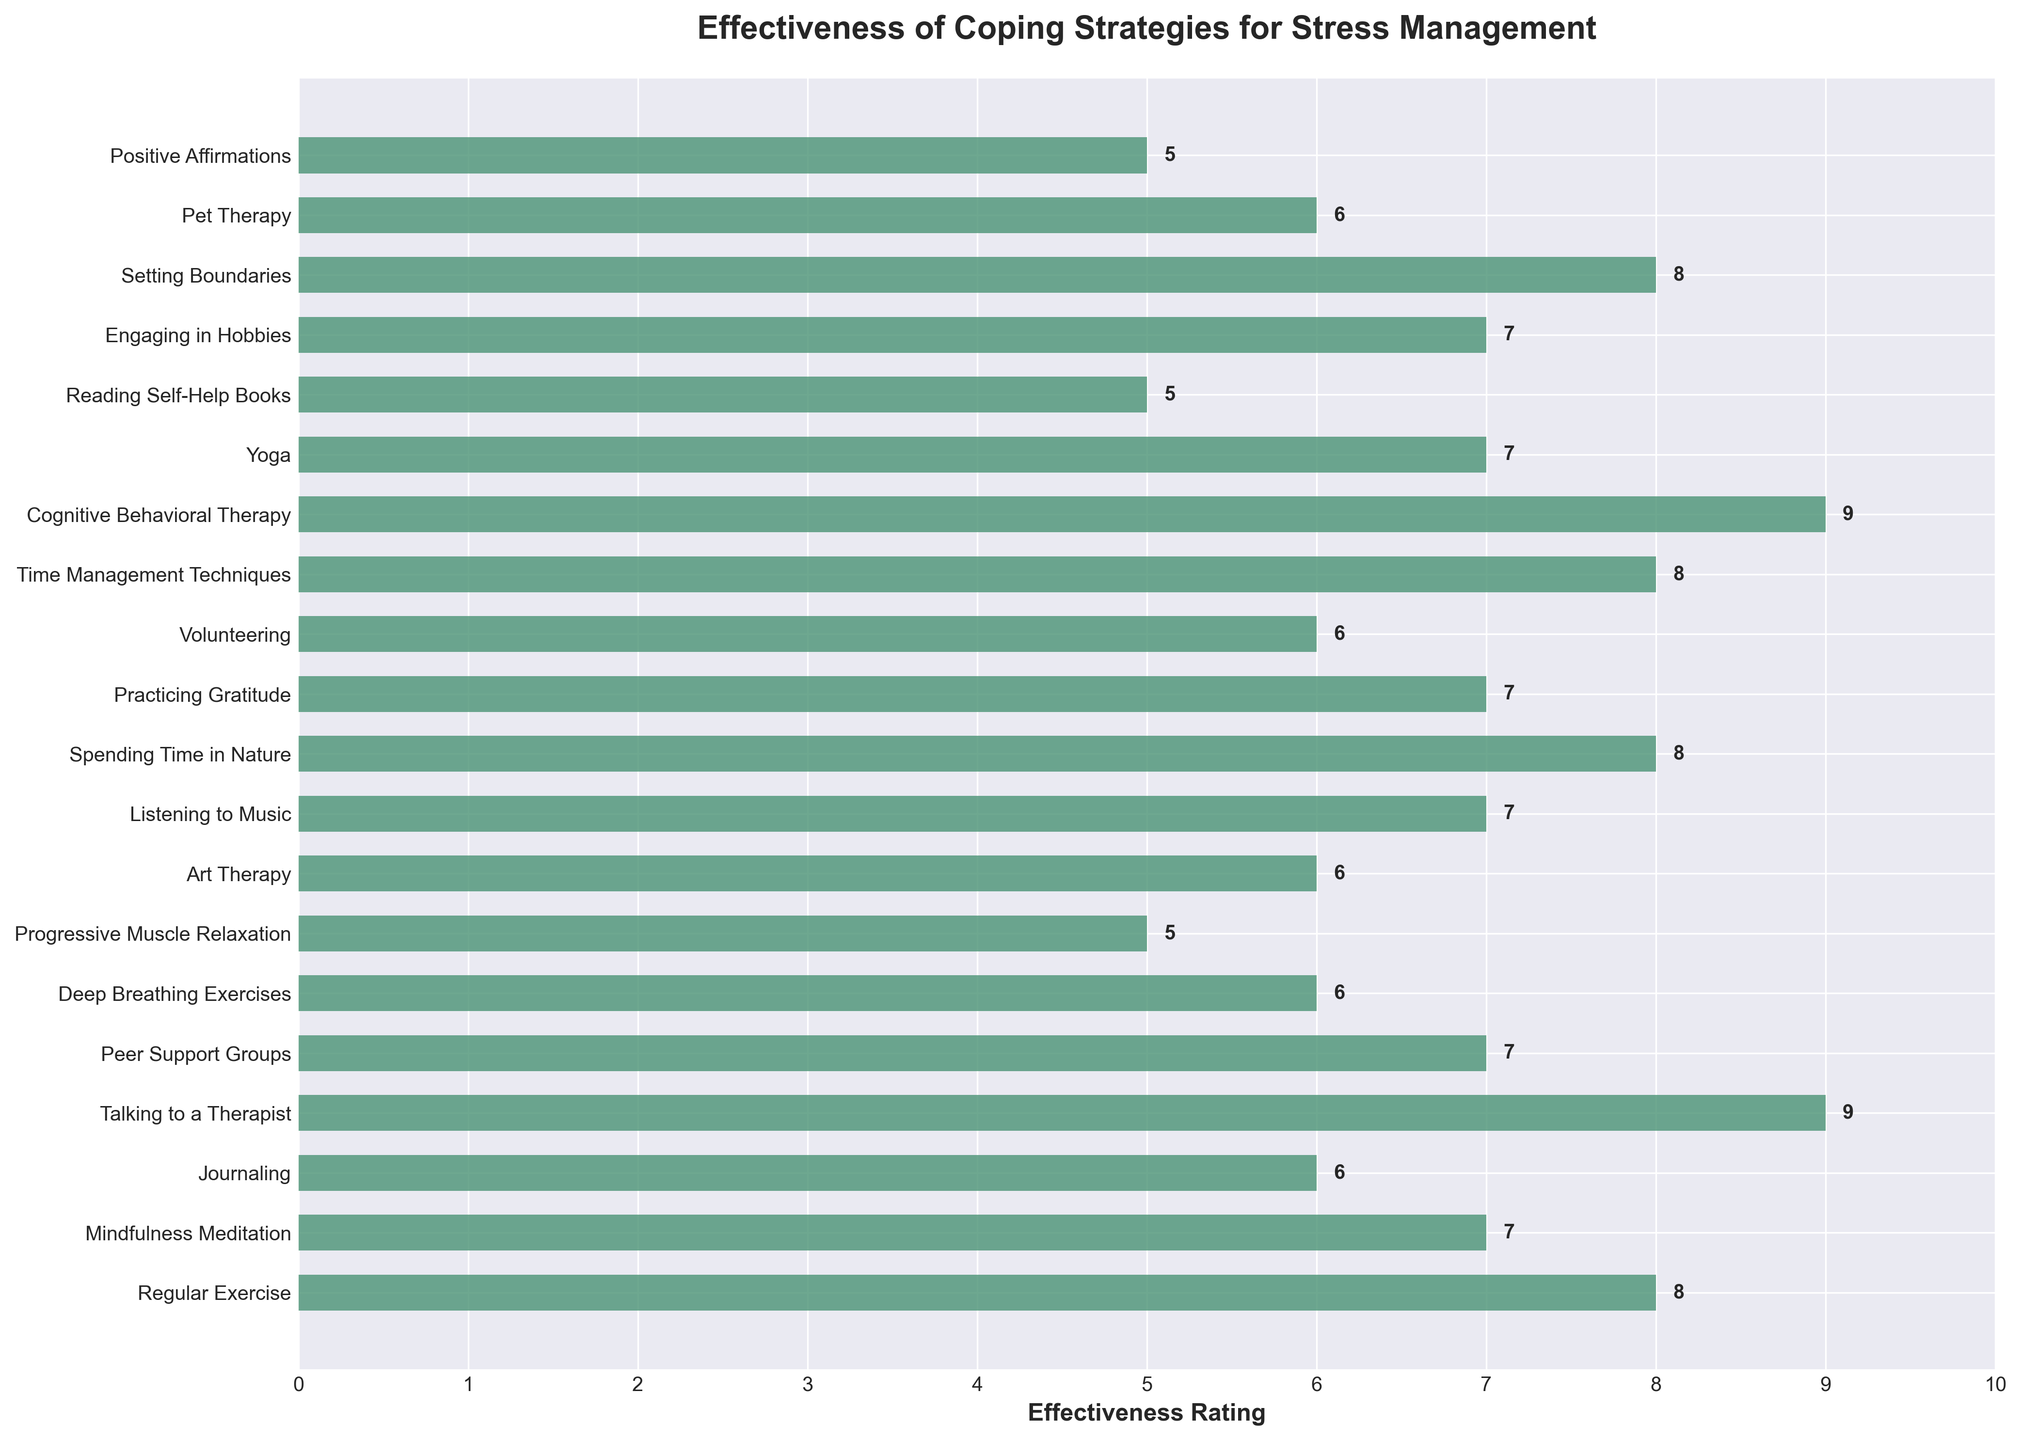Which coping strategy has the highest effectiveness rating? To find the highest effectiveness rating, observe the tallest bar on the chart and note the coping strategy it represents.
Answer: Talking to a Therapist and Cognitive Behavioral Therapy Which coping strategy is rated 8 in effectiveness? Look for the bars that reach the level 8 on the horizontal axis and identify the coping strategies they represent.
Answer: Regular Exercise, Spending Time in Nature, Time Management Techniques, Setting Boundaries What is the effectiveness rating for Pet Therapy? Find the bar representing Pet Therapy and look at its length, then read the corresponding value on the horizontal axis.
Answer: 6 How many coping strategies have an effectiveness rating of 7? Count the bars that reach the level 7 on the horizontal axis.
Answer: 6 Which has a higher effectiveness rating: Journaling or Art Therapy? Compare the lengths of the bars representing Journaling and Art Therapy and refer to the horizontal axis values.
Answer: Art Therapy What is the difference in effectiveness rating between Cognitive Behavioral Therapy and Deep Breathing Exercises? Find the lengths of the bars for Cognitive Behavioral Therapy (rated 9) and Deep Breathing Exercises (rated 6) and subtract the smaller rating from the larger one.
Answer: 3 What is the average effectiveness rating of Progressive Muscle Relaxation and Reading Self-Help Books? Find the lengths of the bars for Progressive Muscle Relaxation and Reading Self-Help Books (both rated 5), sum their ratings, and divide by 2.
Answer: 5 Are there more coping strategies rated above 7 or below 7? Count the bars above and below the level 7 on the horizontal axis and compare the numbers.
Answer: Below 7 Which coping strategies have the same effectiveness rating? Observe the bars at the same level on the horizontal axis and list the corresponding coping strategies.
Answer: Practicing Gratitude, Yoga, Listening to Music, Mindfulness Meditation What is the median effectiveness rating of all the coping strategies? Arrange the effectiveness ratings in ascending order. The middle value for an odd number of total ratings or the average of the two middle values for an even number of ratings is the median. (Ratings: 5, 5, 5, 5, 6, 6, 6, 6, 6, 7, 7, 7, 7, 7, 8, 8, 8, 9, 9) The median is the 10th value.
Answer: 7 